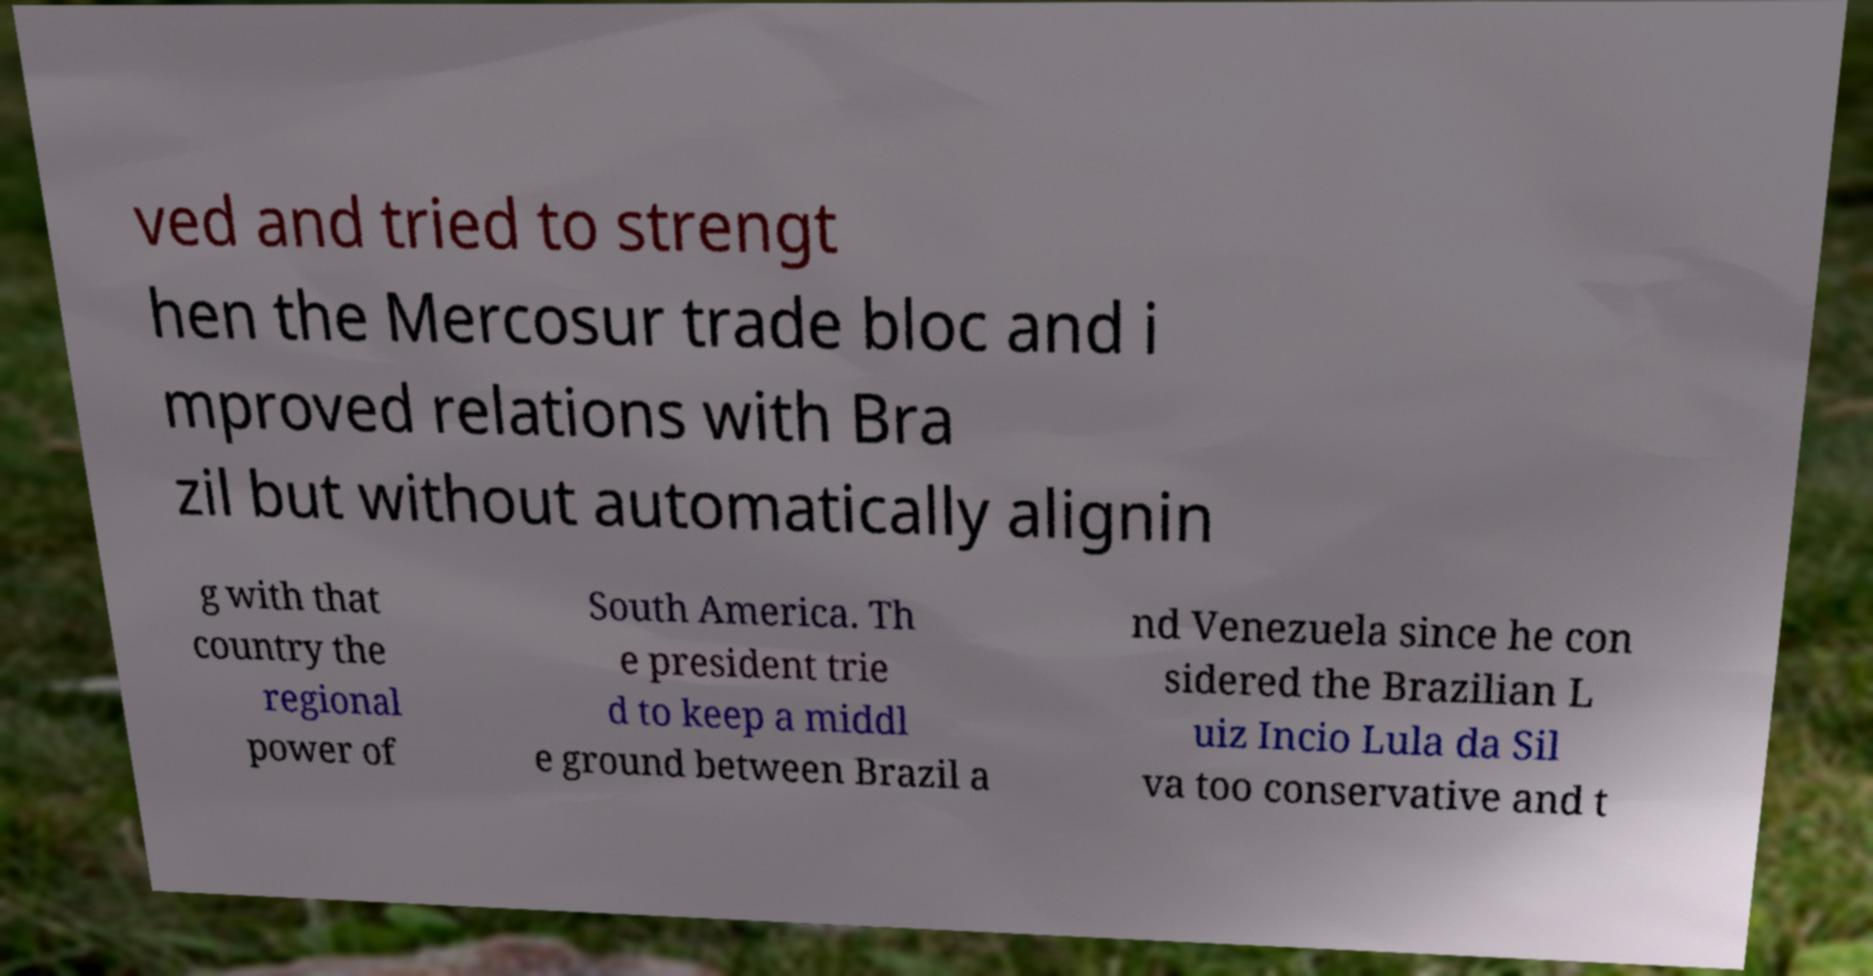Please identify and transcribe the text found in this image. ved and tried to strengt hen the Mercosur trade bloc and i mproved relations with Bra zil but without automatically alignin g with that country the regional power of South America. Th e president trie d to keep a middl e ground between Brazil a nd Venezuela since he con sidered the Brazilian L uiz Incio Lula da Sil va too conservative and t 